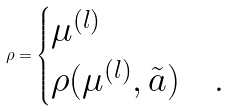Convert formula to latex. <formula><loc_0><loc_0><loc_500><loc_500>\rho = \begin{cases} \mu ^ { ( l ) } & \\ \rho ( \mu ^ { ( l ) } , \tilde { a } ) & . \end{cases}</formula> 